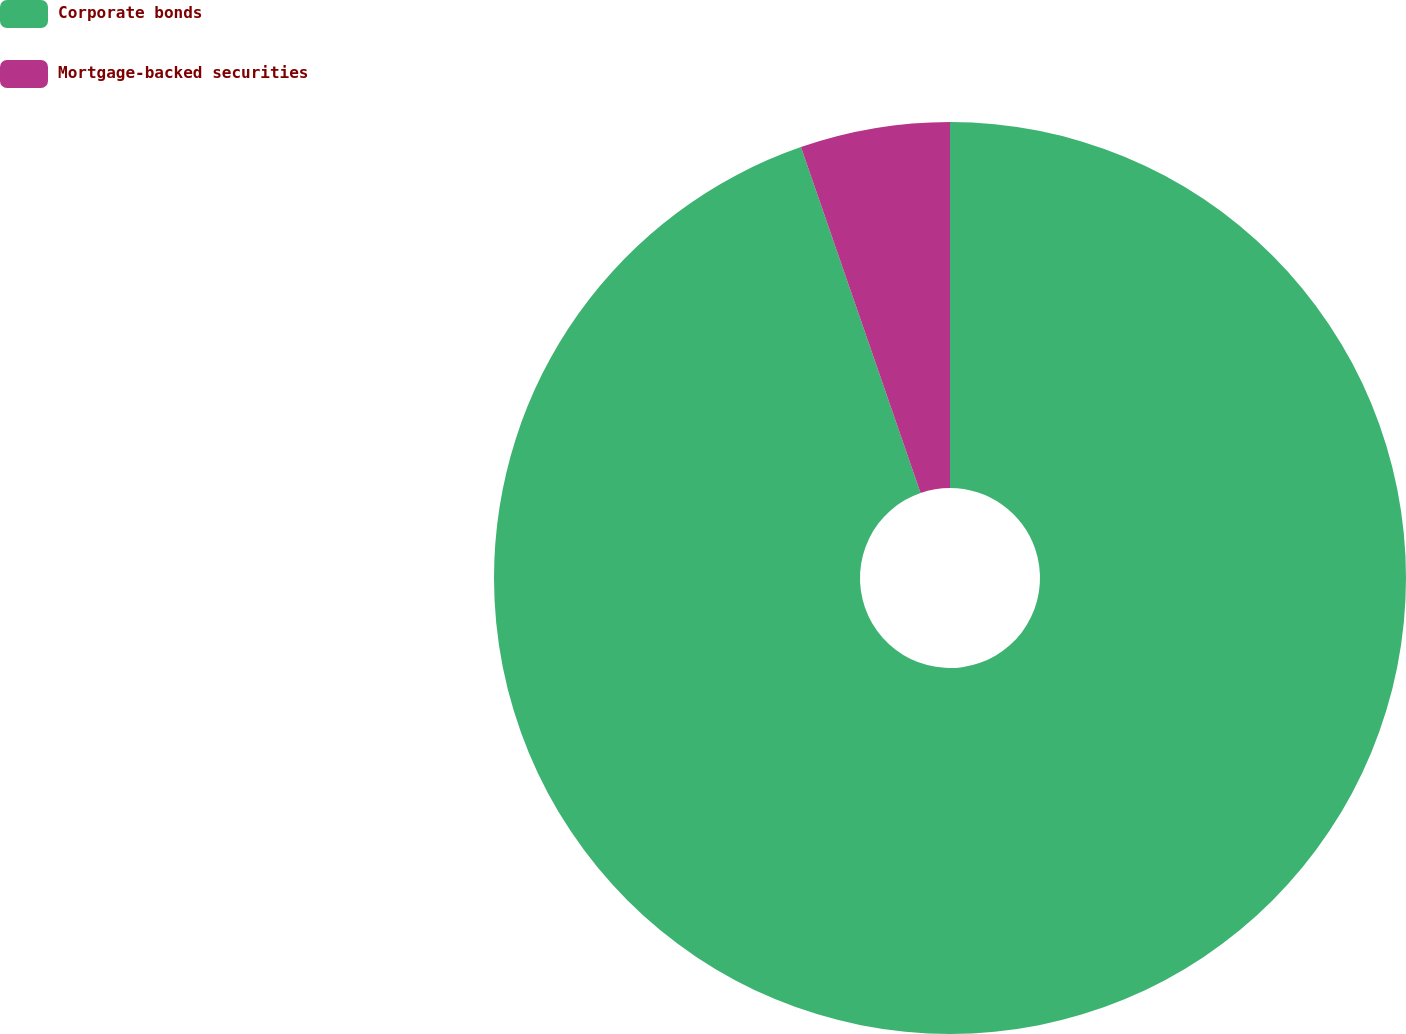Convert chart. <chart><loc_0><loc_0><loc_500><loc_500><pie_chart><fcel>Corporate bonds<fcel>Mortgage-backed securities<nl><fcel>94.7%<fcel>5.3%<nl></chart> 